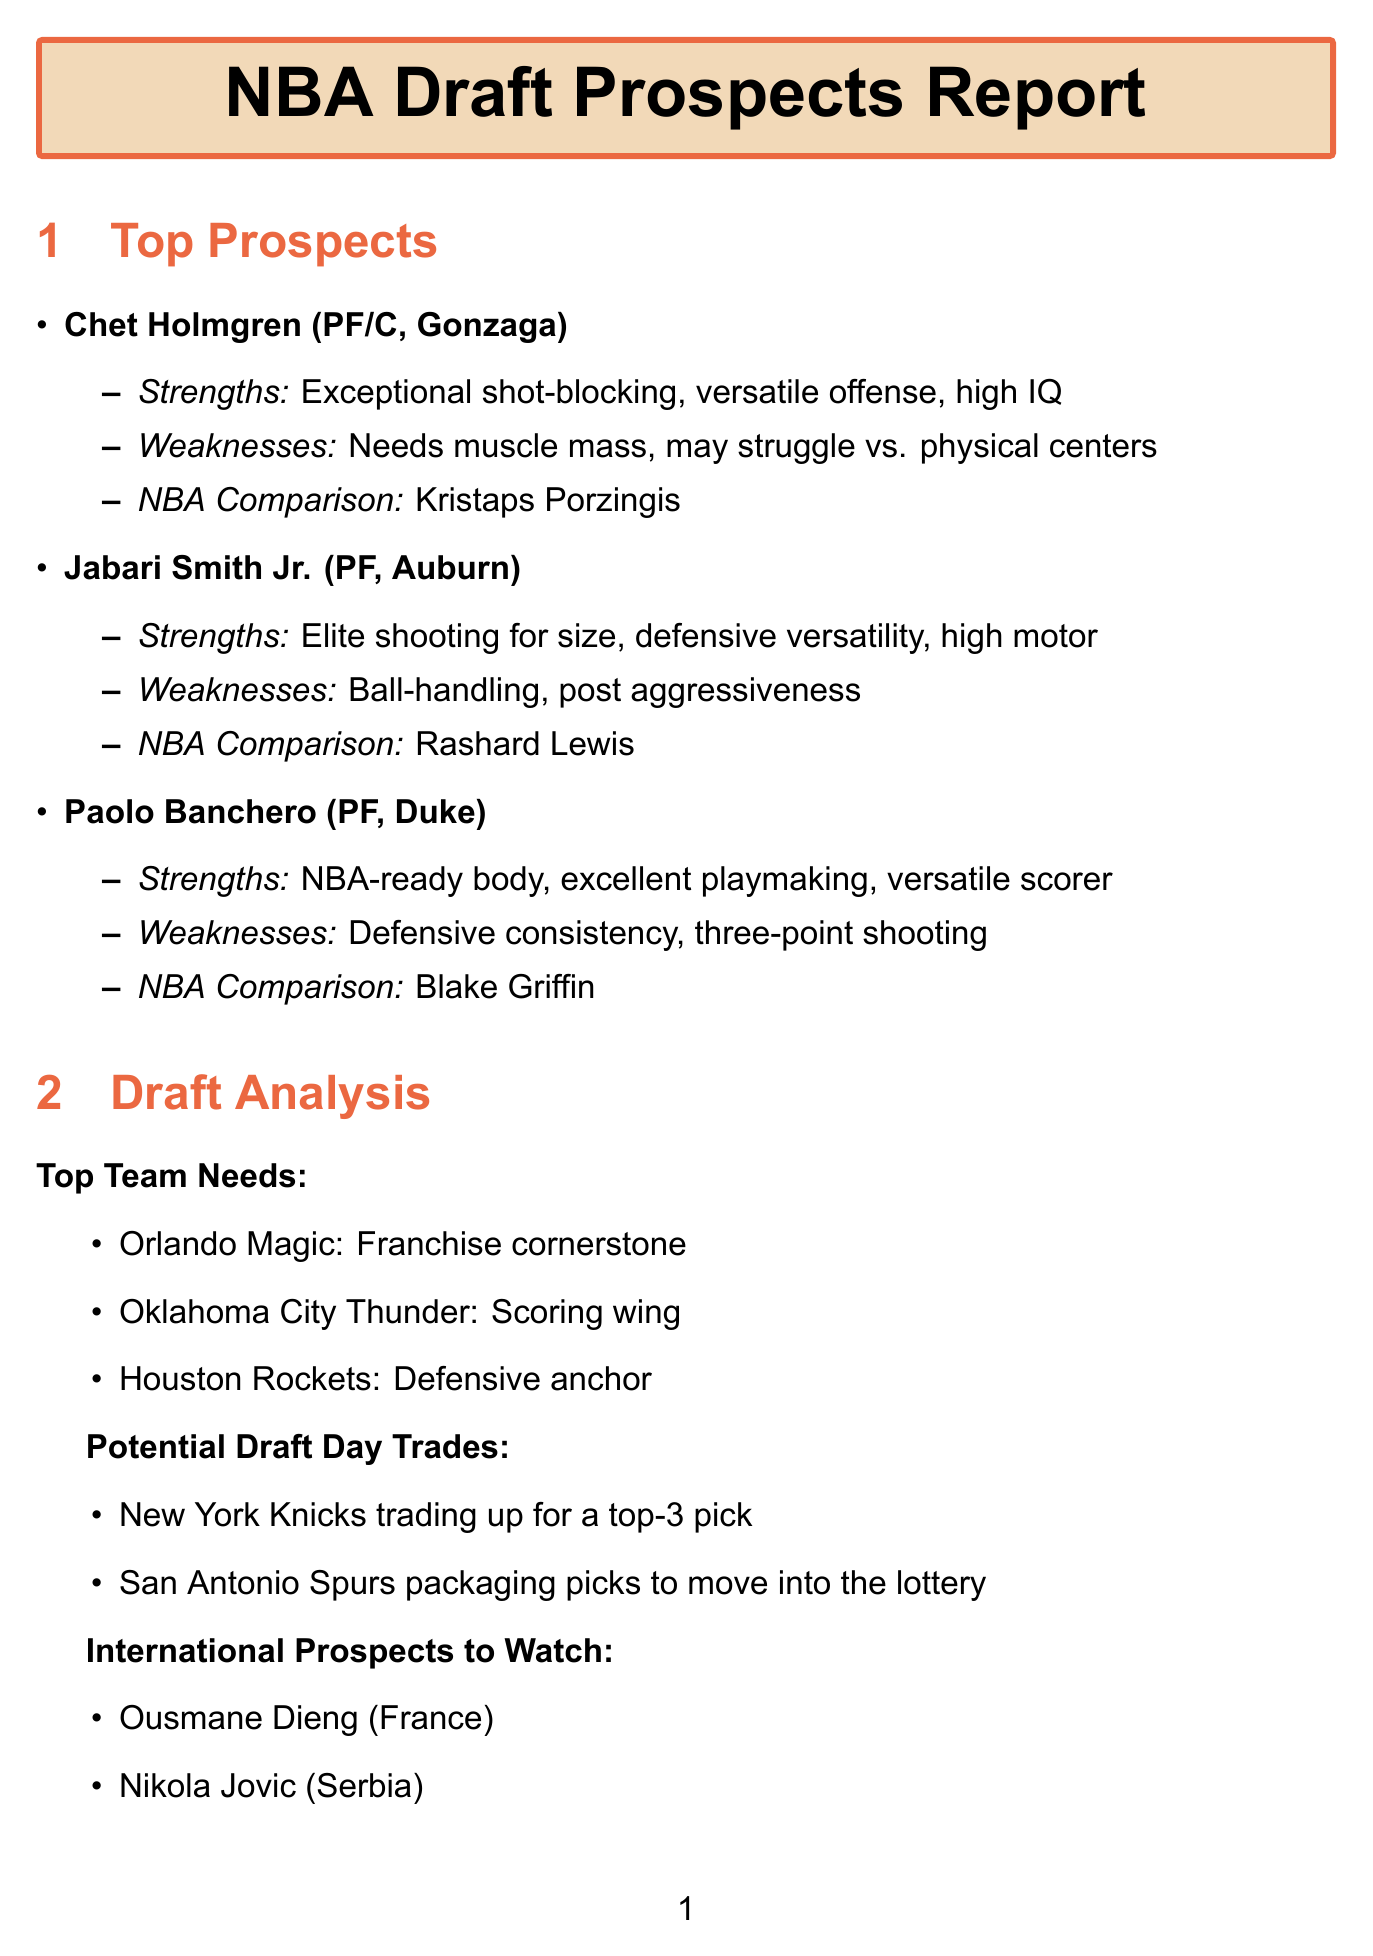What is Chet Holmgren's position? Chet Holmgren is listed as a Power Forward/Center in the document.
Answer: PF/C Which team is looking for a scoring wing? The Oklahoma City Thunder is specifically noted as needing a scoring wing according to the draft analysis.
Answer: Oklahoma City Thunder Name one strength of Paolo Banchero. One of Paolo Banchero's strengths listed in the report is his NBA-ready body.
Answer: NBA-ready body What is the NBA comparison for Jabari Smith Jr.? The report provides Rashard Lewis as the NBA comparison for Jabari Smith Jr.
Answer: Rashard Lewis Who had the highest vertical leap at the draft combine? Jaden Ivey recorded the highest vertical leap at the draft combine.
Answer: Jaden Ivey What are the two international prospects mentioned? The report highlights Ousmane Dieng and Nikola Jovic as international prospects.
Answer: Ousmane Dieng, Nikola Jovic Which NBA team is focused on the best player available approach? The Detroit Pistons are noted for taking the best player available approach.
Answer: Detroit Pistons What weakness is noted for Jabari Smith Jr.? The document indicates that Jabari Smith Jr. needs to improve his ball-handling as a weakness.
Answer: Needs to improve ball-handling Which college player is compared to Blake Griffin? Paolo Banchero is compared to Blake Griffin in the scouting report.
Answer: Paolo Banchero 